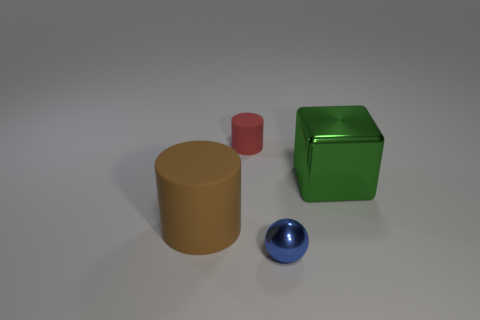Add 3 shiny objects. How many objects exist? 7 Subtract all blocks. How many objects are left? 3 Subtract all tiny red rubber things. Subtract all big gray matte cylinders. How many objects are left? 3 Add 3 large green objects. How many large green objects are left? 4 Add 3 big brown rubber cylinders. How many big brown rubber cylinders exist? 4 Subtract 0 yellow blocks. How many objects are left? 4 